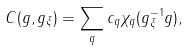Convert formula to latex. <formula><loc_0><loc_0><loc_500><loc_500>C ( g , g _ { \xi } ) = \sum _ { q } c _ { q } \chi _ { q } ( g _ { \xi } ^ { - 1 } g ) ,</formula> 